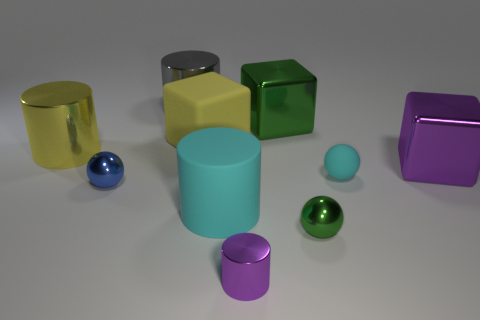Are there more large yellow objects that are on the right side of the small blue metal ball than cyan matte spheres?
Make the answer very short. No. Are there any other tiny green things of the same shape as the tiny green metal thing?
Provide a succinct answer. No. Do the cyan ball and the large cylinder behind the big yellow matte object have the same material?
Provide a succinct answer. No. The rubber ball is what color?
Provide a short and direct response. Cyan. There is a tiny purple shiny cylinder in front of the green thing on the left side of the tiny green ball; how many shiny cylinders are on the left side of it?
Keep it short and to the point. 2. There is a tiny blue shiny ball; are there any small cyan rubber spheres in front of it?
Give a very brief answer. No. How many small purple objects have the same material as the small blue ball?
Make the answer very short. 1. What number of things are either yellow cylinders or tiny cyan rubber balls?
Your answer should be compact. 2. Are there any cyan matte cylinders?
Your answer should be very brief. Yes. There is a big cube that is right of the green object in front of the large object that is to the right of the small green ball; what is it made of?
Provide a short and direct response. Metal. 